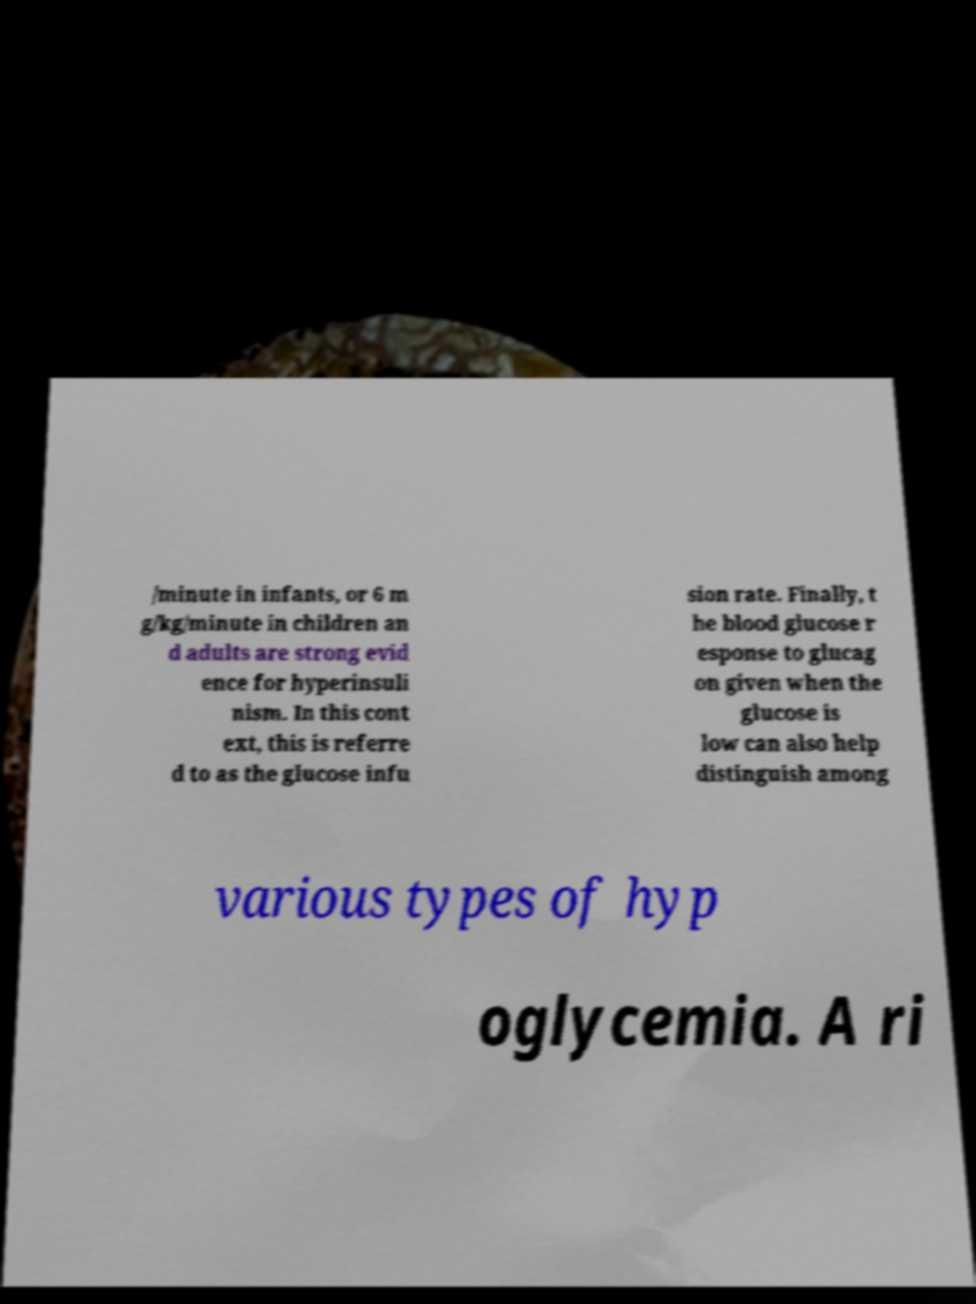Please read and relay the text visible in this image. What does it say? /minute in infants, or 6 m g/kg/minute in children an d adults are strong evid ence for hyperinsuli nism. In this cont ext, this is referre d to as the glucose infu sion rate. Finally, t he blood glucose r esponse to glucag on given when the glucose is low can also help distinguish among various types of hyp oglycemia. A ri 